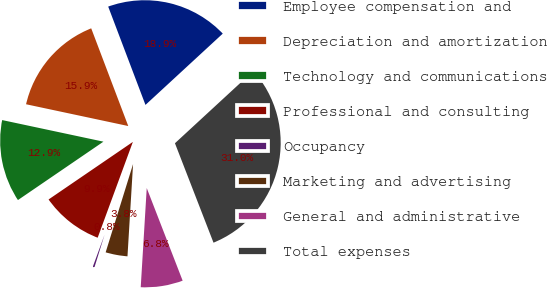Convert chart to OTSL. <chart><loc_0><loc_0><loc_500><loc_500><pie_chart><fcel>Employee compensation and<fcel>Depreciation and amortization<fcel>Technology and communications<fcel>Professional and consulting<fcel>Occupancy<fcel>Marketing and advertising<fcel>General and administrative<fcel>Total expenses<nl><fcel>18.91%<fcel>15.89%<fcel>12.88%<fcel>9.86%<fcel>0.81%<fcel>3.83%<fcel>6.85%<fcel>30.97%<nl></chart> 